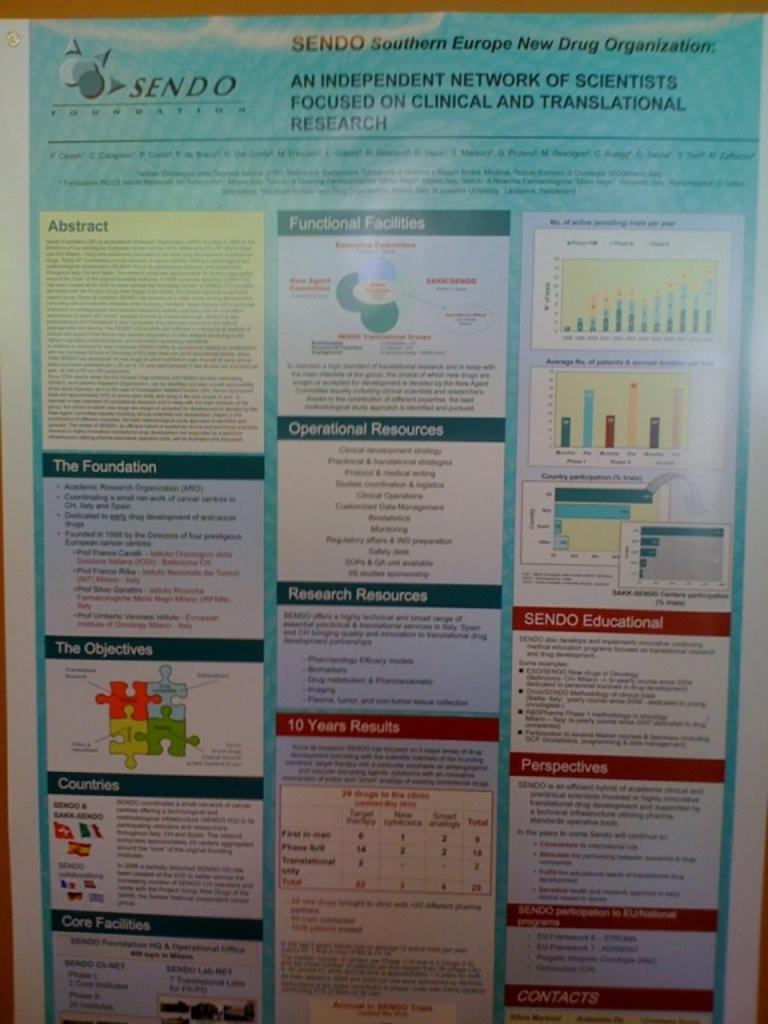What does sendo stand for?
Make the answer very short. Southern europe new drug organization. What is this an independent network of?
Provide a succinct answer. Scientists. 